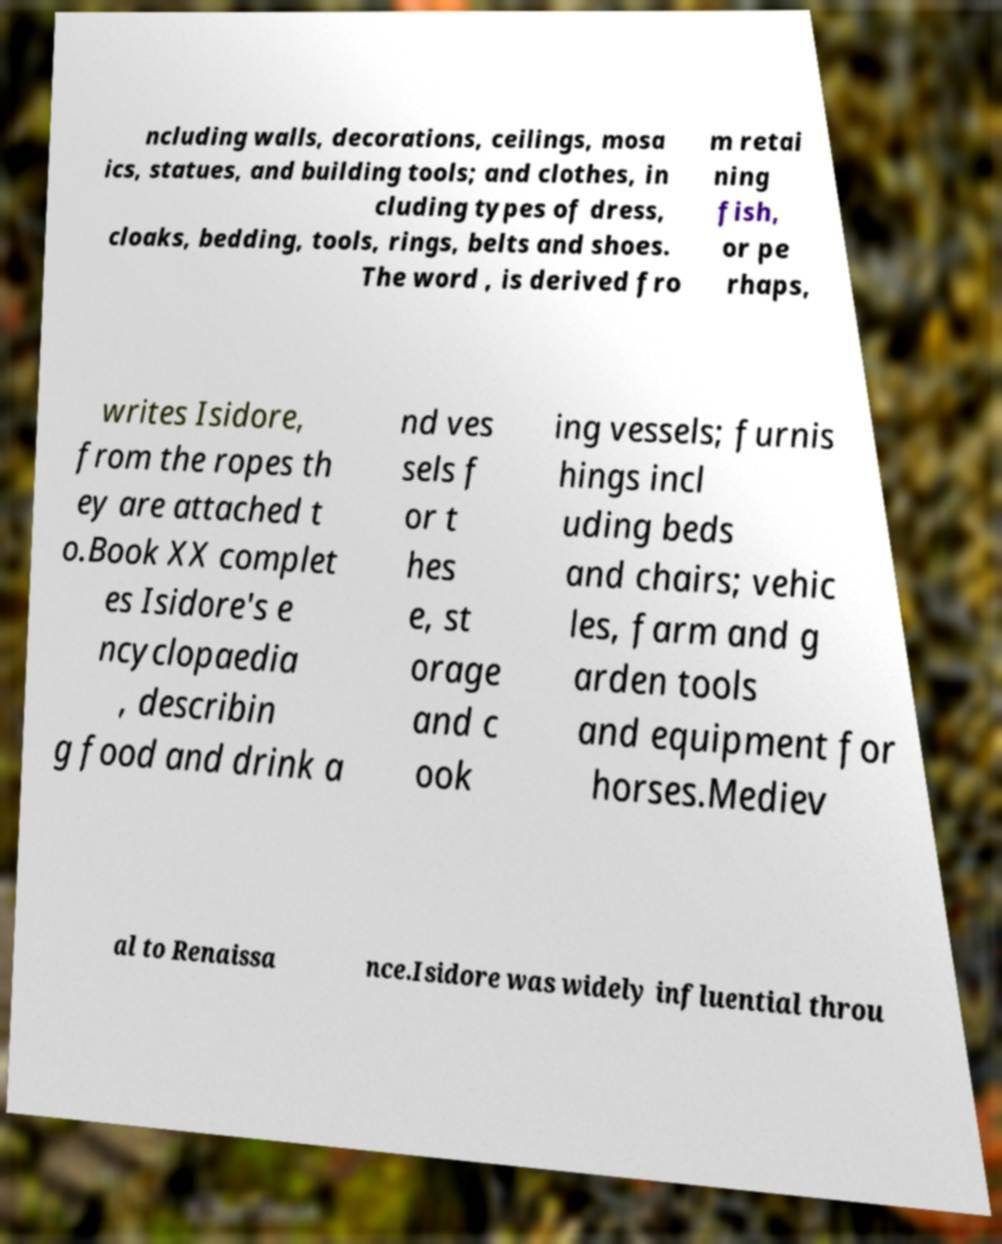Can you read and provide the text displayed in the image?This photo seems to have some interesting text. Can you extract and type it out for me? ncluding walls, decorations, ceilings, mosa ics, statues, and building tools; and clothes, in cluding types of dress, cloaks, bedding, tools, rings, belts and shoes. The word , is derived fro m retai ning fish, or pe rhaps, writes Isidore, from the ropes th ey are attached t o.Book XX complet es Isidore's e ncyclopaedia , describin g food and drink a nd ves sels f or t hes e, st orage and c ook ing vessels; furnis hings incl uding beds and chairs; vehic les, farm and g arden tools and equipment for horses.Mediev al to Renaissa nce.Isidore was widely influential throu 